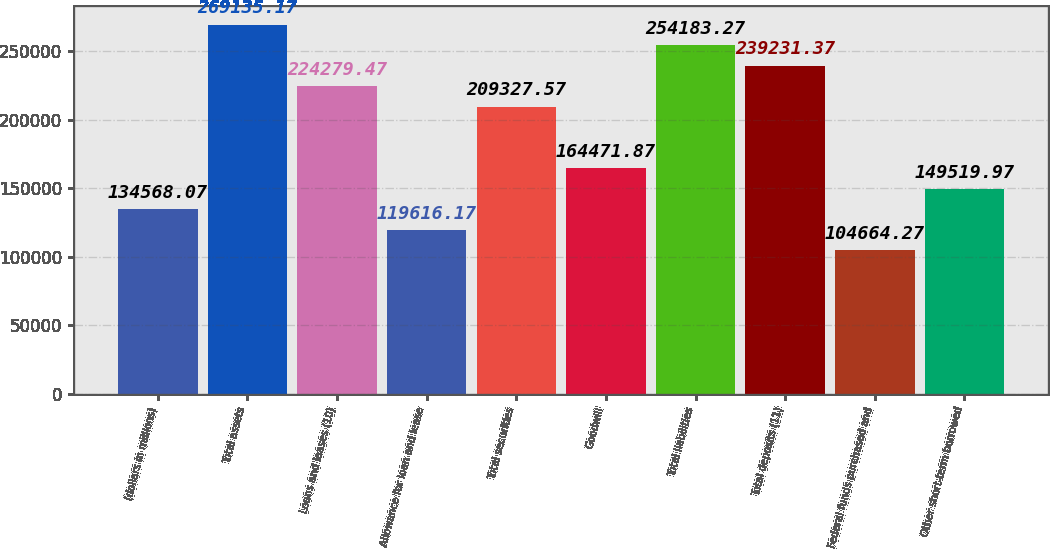Convert chart to OTSL. <chart><loc_0><loc_0><loc_500><loc_500><bar_chart><fcel>(dollars in millions)<fcel>Total assets<fcel>Loans and leases (10)<fcel>Allowance for loan and lease<fcel>Total securities<fcel>Goodwill<fcel>Total liabilities<fcel>Total deposits (11)<fcel>Federal funds purchased and<fcel>Other short-term borrowed<nl><fcel>134568<fcel>269135<fcel>224279<fcel>119616<fcel>209328<fcel>164472<fcel>254183<fcel>239231<fcel>104664<fcel>149520<nl></chart> 